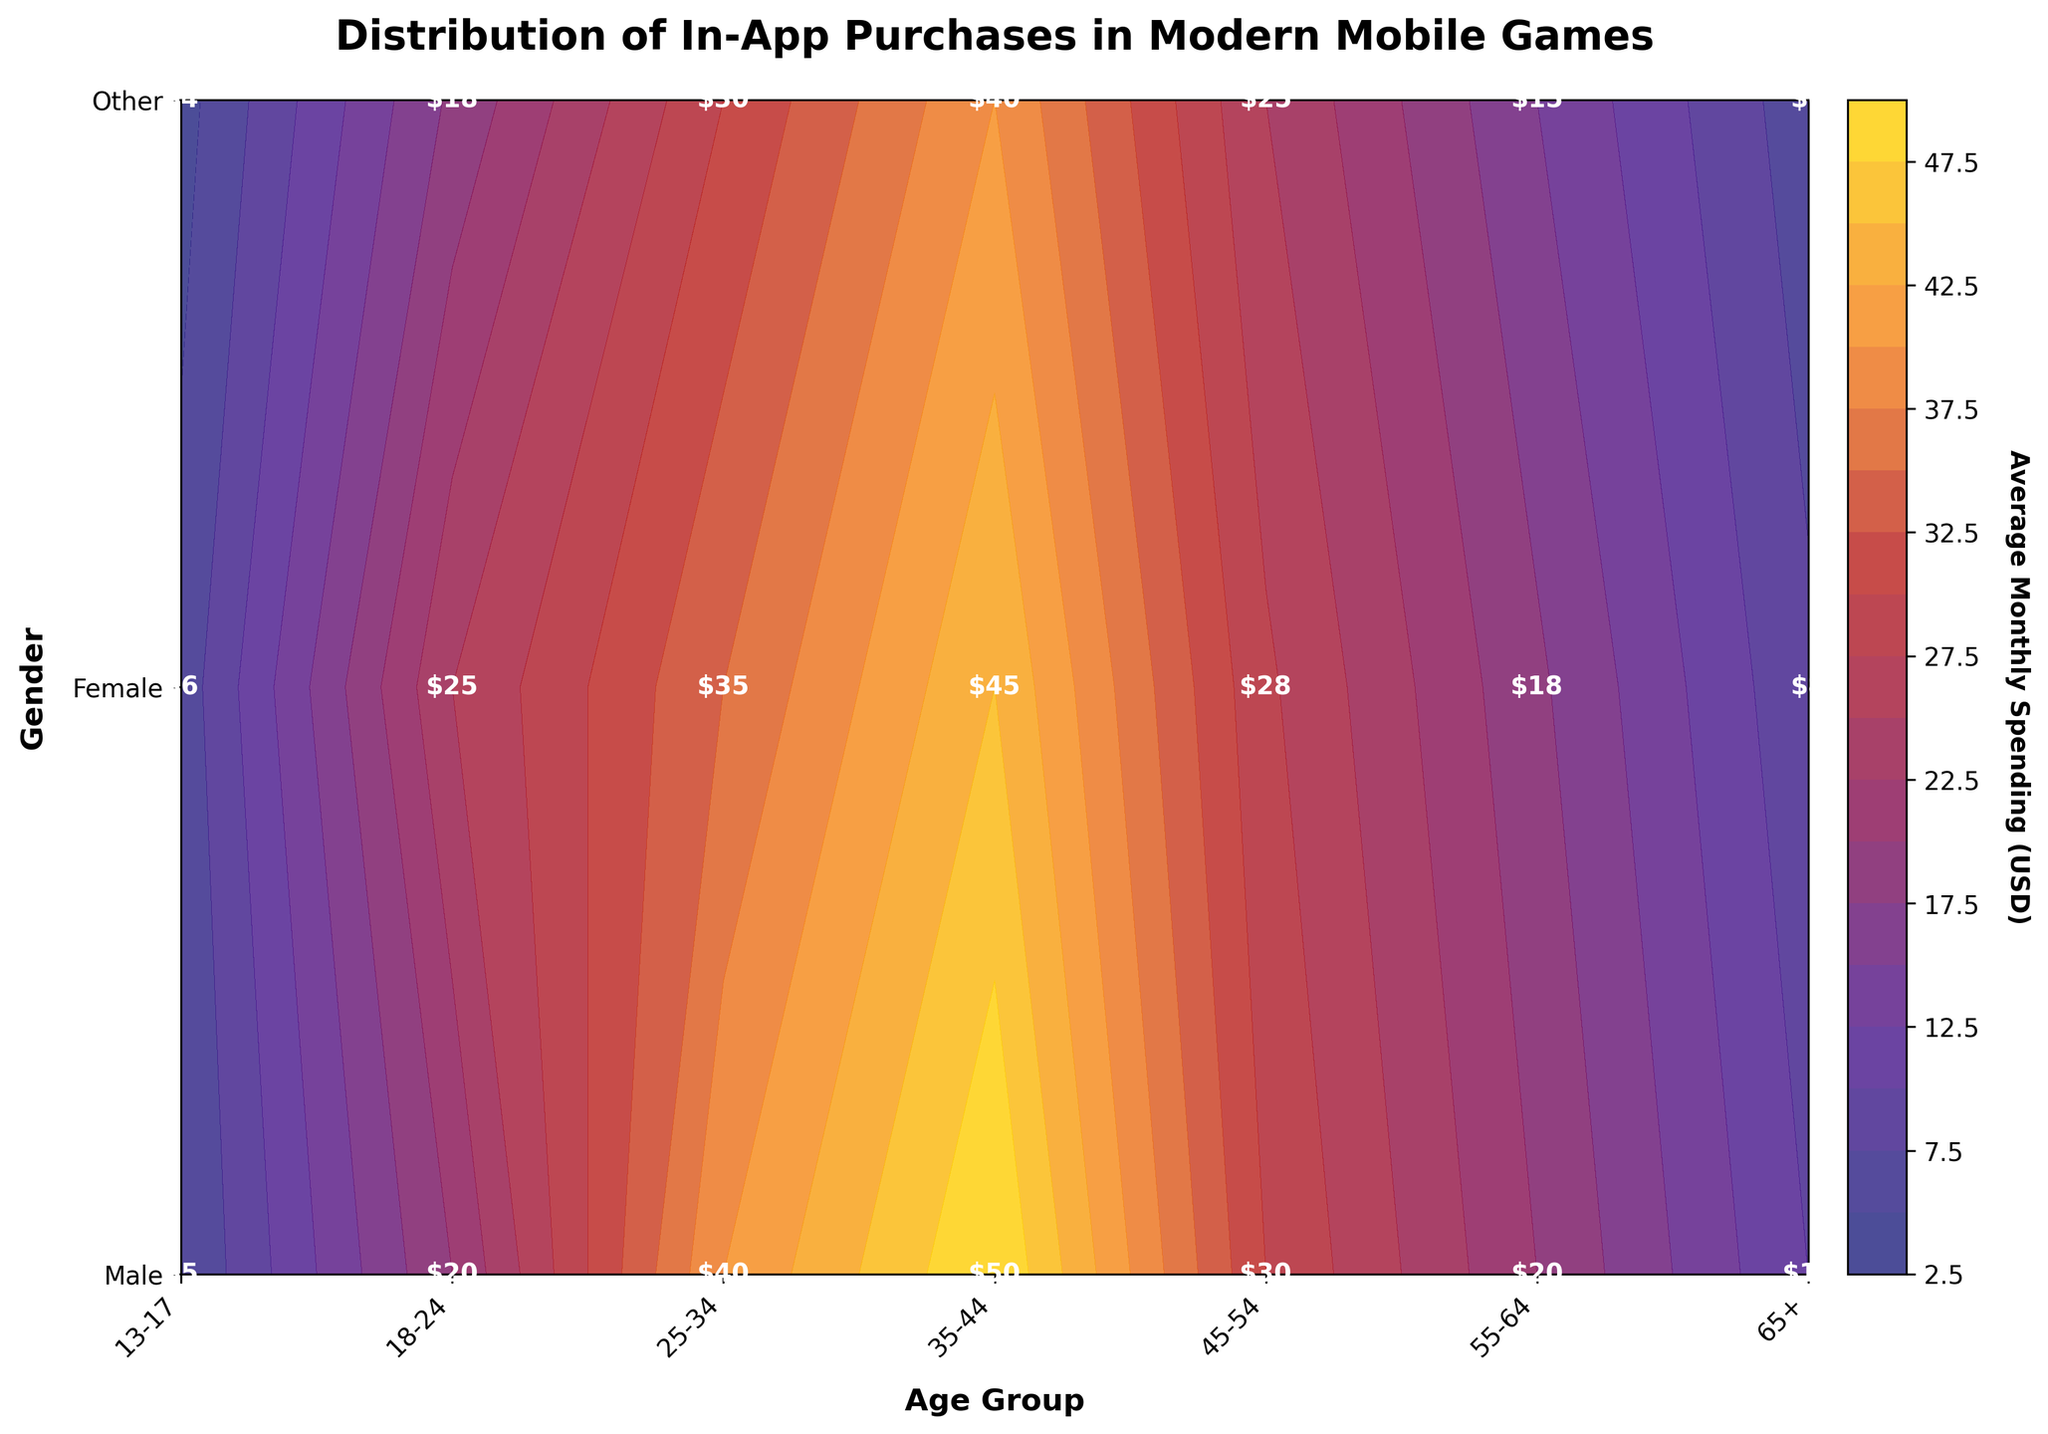What is the title of the plot? The title of the plot is usually located at the top center and provides a summary of the figure. In this case, the title is "Distribution of In-App Purchases in Modern Mobile Games".
Answer: Distribution of In-App Purchases in Modern Mobile Games What age group has the highest average spending for males? To determine this, we scan the contour plot's labels within the Male row for the highest value. The highest value for males is in the 35-44 age group, which is $50.
Answer: 35-44 For the 'Other' gender category, which age group has the lowest spending? Look at the row corresponding to 'Other' and find the minimum value among all age groups. The lowest value is in the 13-17 age group with a spending of $4.
Answer: 13-17 What is the color corresponding to the highest average spending on the color bar? Identify the highest value displayed on the color bar, then observe the color associated with this value. The highest spending value is $50, and its color is a bright yellow.
Answer: Bright yellow Compare the average monthly spending between males and females in the 18-24 age group. Who spends more and by how much? Identify the spending amounts for males and females in the 18-24 age group. Males spend $20 and females spend $25. Calculate the difference: $25 - $20 = $5.
Answer: Females spend $5 more What is the sum of average monthly spending for the 25-34 age group across all genders? Locate the values for the 25-34 age group for all gender categories and sum them up: $40 (Male) + $35 (Female) + $30 (Other) = $105.
Answer: $105 Which age group shows the most uniform spending across all genders? Look for the age group where the spending values across all genders are the closest to each other. For the 55-64 age group, the values are $20, $18, $15 which are relatively close.
Answer: 55-64 What is the level (in terms of spending) at the center of the plot? The center is at '35-44' age group and 'Female' gender. Observe the contour label at this intersection. The value is $45.
Answer: $45 Which gender has the most varied spending across different age groups? Compare the range (difference between highest and lowest values) for each gender. For 'Male', the range is $50 - $5 = $45. For 'Female', the range is $45 - $6 = $39. For 'Other', the range is $40 - $4 = $36. The most varied spending is for males.
Answer: Male 